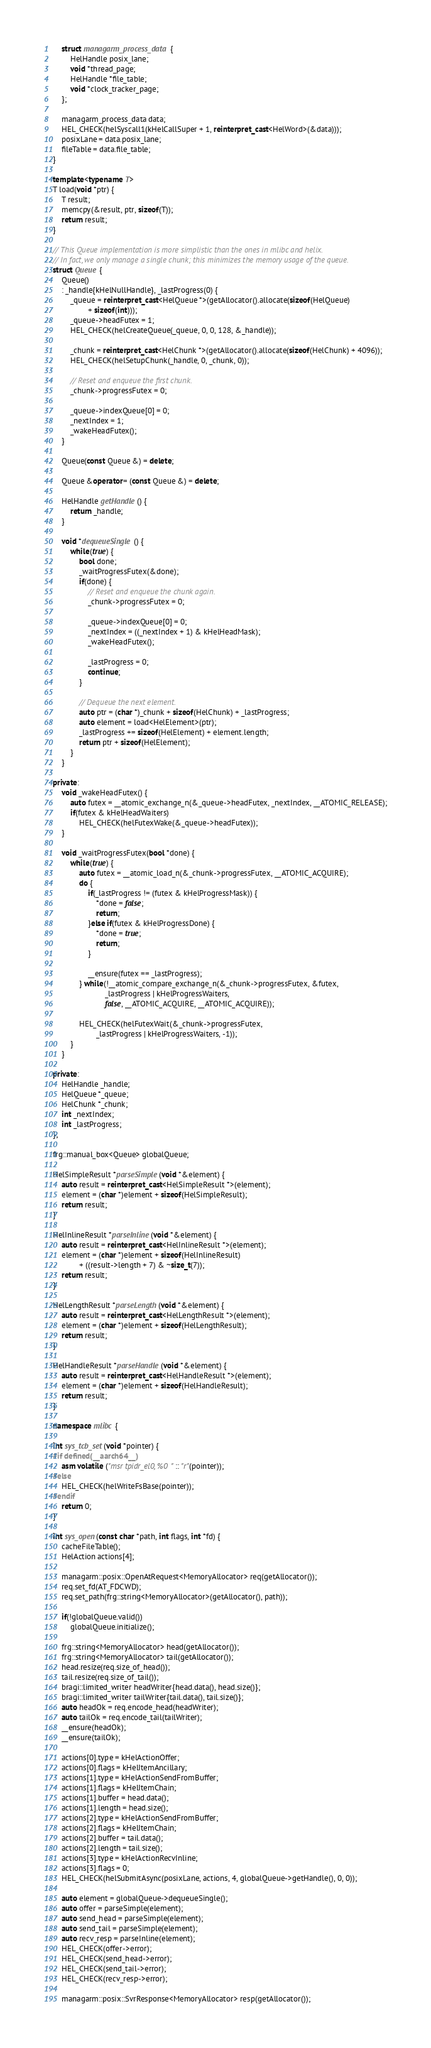<code> <loc_0><loc_0><loc_500><loc_500><_C++_>
	struct managarm_process_data {
		HelHandle posix_lane;
		void *thread_page;
		HelHandle *file_table;
		void *clock_tracker_page;
	};

	managarm_process_data data;
	HEL_CHECK(helSyscall1(kHelCallSuper + 1, reinterpret_cast<HelWord>(&data)));
	posixLane = data.posix_lane;
	fileTable = data.file_table;
}

template<typename T>
T load(void *ptr) {
	T result;
	memcpy(&result, ptr, sizeof(T));
	return result;
}

// This Queue implementation is more simplistic than the ones in mlibc and helix.
// In fact, we only manage a single chunk; this minimizes the memory usage of the queue.
struct Queue {
	Queue()
	: _handle{kHelNullHandle}, _lastProgress(0) {
		_queue = reinterpret_cast<HelQueue *>(getAllocator().allocate(sizeof(HelQueue)
				+ sizeof(int)));
		_queue->headFutex = 1;
		HEL_CHECK(helCreateQueue(_queue, 0, 0, 128, &_handle));

		_chunk = reinterpret_cast<HelChunk *>(getAllocator().allocate(sizeof(HelChunk) + 4096));
		HEL_CHECK(helSetupChunk(_handle, 0, _chunk, 0));

		// Reset and enqueue the first chunk.
		_chunk->progressFutex = 0;

		_queue->indexQueue[0] = 0;
		_nextIndex = 1;
		_wakeHeadFutex();
	}

	Queue(const Queue &) = delete;

	Queue &operator= (const Queue &) = delete;

	HelHandle getHandle() {
		return _handle;
	}

	void *dequeueSingle() {
		while(true) {
			bool done;
			_waitProgressFutex(&done);
			if(done) {
				// Reset and enqueue the chunk again.
				_chunk->progressFutex = 0;

				_queue->indexQueue[0] = 0;
				_nextIndex = ((_nextIndex + 1) & kHelHeadMask);
				_wakeHeadFutex();

				_lastProgress = 0;
				continue;
			}

			// Dequeue the next element.
			auto ptr = (char *)_chunk + sizeof(HelChunk) + _lastProgress;
			auto element = load<HelElement>(ptr);
			_lastProgress += sizeof(HelElement) + element.length;
			return ptr + sizeof(HelElement);
		}
	}

private:
	void _wakeHeadFutex() {
		auto futex = __atomic_exchange_n(&_queue->headFutex, _nextIndex, __ATOMIC_RELEASE);
		if(futex & kHelHeadWaiters)
			HEL_CHECK(helFutexWake(&_queue->headFutex));
	}

	void _waitProgressFutex(bool *done) {
		while(true) {
			auto futex = __atomic_load_n(&_chunk->progressFutex, __ATOMIC_ACQUIRE);
			do {
				if(_lastProgress != (futex & kHelProgressMask)) {
					*done = false;
					return;
				}else if(futex & kHelProgressDone) {
					*done = true;
					return;
				}

				__ensure(futex == _lastProgress);
			} while(!__atomic_compare_exchange_n(&_chunk->progressFutex, &futex,
						_lastProgress | kHelProgressWaiters,
						false, __ATOMIC_ACQUIRE, __ATOMIC_ACQUIRE));

			HEL_CHECK(helFutexWait(&_chunk->progressFutex,
					_lastProgress | kHelProgressWaiters, -1));
		}
	}

private:
	HelHandle _handle;
	HelQueue *_queue;
	HelChunk *_chunk;
	int _nextIndex;
	int _lastProgress;
};

frg::manual_box<Queue> globalQueue;

HelSimpleResult *parseSimple(void *&element) {
	auto result = reinterpret_cast<HelSimpleResult *>(element);
	element = (char *)element + sizeof(HelSimpleResult);
	return result;
}

HelInlineResult *parseInline(void *&element) {
	auto result = reinterpret_cast<HelInlineResult *>(element);
	element = (char *)element + sizeof(HelInlineResult)
			+ ((result->length + 7) & ~size_t(7));
	return result;
}

HelLengthResult *parseLength(void *&element) {
	auto result = reinterpret_cast<HelLengthResult *>(element);
	element = (char *)element + sizeof(HelLengthResult);
	return result;
}

HelHandleResult *parseHandle(void *&element) {
	auto result = reinterpret_cast<HelHandleResult *>(element);
	element = (char *)element + sizeof(HelHandleResult);
	return result;
}

namespace mlibc {

int sys_tcb_set(void *pointer) {
#if defined(__aarch64__)
	asm volatile ("msr tpidr_el0, %0" :: "r"(pointer));
#else
	HEL_CHECK(helWriteFsBase(pointer));
#endif
	return 0;
}

int sys_open(const char *path, int flags, int *fd) {
	cacheFileTable();
	HelAction actions[4];

	managarm::posix::OpenAtRequest<MemoryAllocator> req(getAllocator());
	req.set_fd(AT_FDCWD);
	req.set_path(frg::string<MemoryAllocator>(getAllocator(), path));

	if(!globalQueue.valid())
		globalQueue.initialize();

	frg::string<MemoryAllocator> head(getAllocator());
	frg::string<MemoryAllocator> tail(getAllocator());
	head.resize(req.size_of_head());
	tail.resize(req.size_of_tail());
	bragi::limited_writer headWriter{head.data(), head.size()};
	bragi::limited_writer tailWriter{tail.data(), tail.size()};
	auto headOk = req.encode_head(headWriter);
	auto tailOk = req.encode_tail(tailWriter);
	__ensure(headOk);
	__ensure(tailOk);

	actions[0].type = kHelActionOffer;
	actions[0].flags = kHelItemAncillary;
	actions[1].type = kHelActionSendFromBuffer;
	actions[1].flags = kHelItemChain;
	actions[1].buffer = head.data();
	actions[1].length = head.size();
	actions[2].type = kHelActionSendFromBuffer;
	actions[2].flags = kHelItemChain;
	actions[2].buffer = tail.data();
	actions[2].length = tail.size();
	actions[3].type = kHelActionRecvInline;
	actions[3].flags = 0;
	HEL_CHECK(helSubmitAsync(posixLane, actions, 4, globalQueue->getHandle(), 0, 0));

	auto element = globalQueue->dequeueSingle();
	auto offer = parseSimple(element);
	auto send_head = parseSimple(element);
	auto send_tail = parseSimple(element);
	auto recv_resp = parseInline(element);
	HEL_CHECK(offer->error);
	HEL_CHECK(send_head->error);
	HEL_CHECK(send_tail->error);
	HEL_CHECK(recv_resp->error);

	managarm::posix::SvrResponse<MemoryAllocator> resp(getAllocator());</code> 